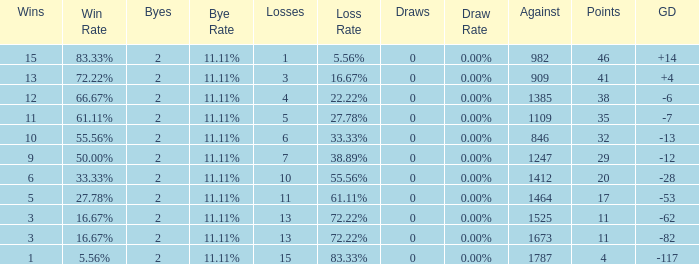Can you give me this table as a dict? {'header': ['Wins', 'Win Rate', 'Byes', 'Bye Rate', 'Losses', 'Loss Rate', 'Draws', 'Draw Rate', 'Against', 'Points', 'GD'], 'rows': [['15', '83.33%', '2', '11.11%', '1', '5.56%', '0', '0.00%', '982', '46', '+14'], ['13', '72.22%', '2', '11.11%', '3', '16.67%', '0', '0.00%', '909', '41', '+4'], ['12', '66.67%', '2', '11.11%', '4', '22.22%', '0', '0.00%', '1385', '38', '-6'], ['11', '61.11%', '2', '11.11%', '5', '27.78%', '0', '0.00%', '1109', '35', '-7'], ['10', '55.56%', '2', '11.11%', '6', '33.33%', '0', '0.00%', '846', '32', '-13'], ['9', '50.00%', '2', '11.11%', '7', '38.89%', '0', '0.00%', '1247', '29', '-12'], ['6', '33.33%', '2', '11.11%', '10', '55.56%', '0', '0.00%', '1412', '20', '-28'], ['5', '27.78%', '2', '11.11%', '11', '61.11%', '0', '0.00%', '1464', '17', '-53'], ['3', '16.67%', '2', '11.11%', '13', '72.22%', '0', '0.00%', '1525', '11', '-62'], ['3', '16.67%', '2', '11.11%', '13', '72.22%', '0', '0.00%', '1673', '11', '-82'], ['1', '5.56%', '2', '11.11%', '15', '83.33%', '0', '0.00%', '1787', '4', '-117']]} What is the highest number listed under against when there were 15 losses and more than 1 win? None. 